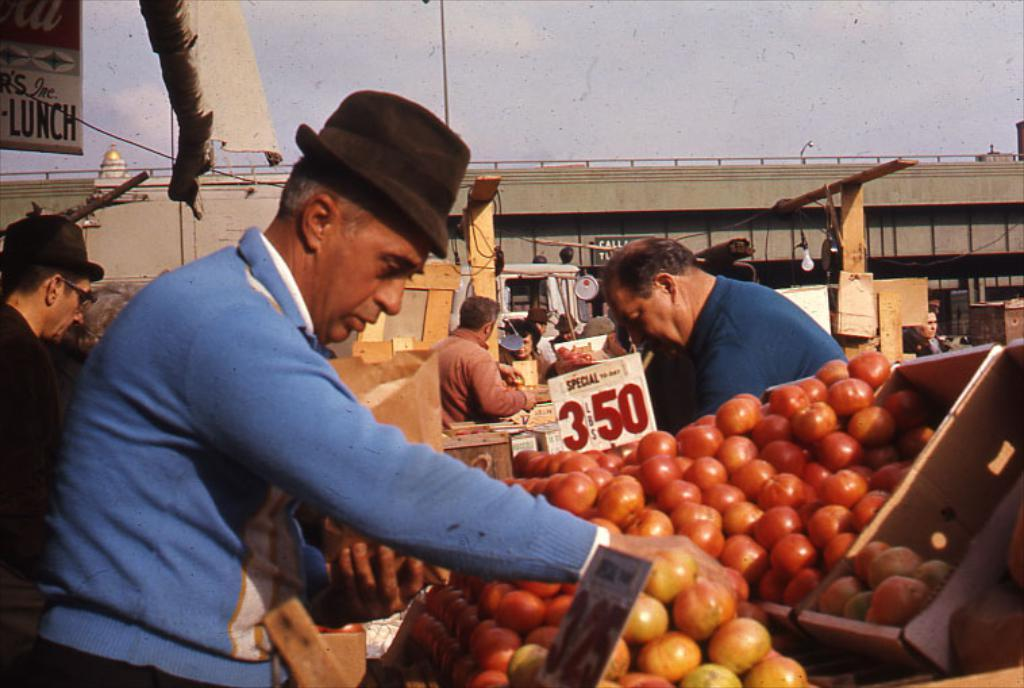How many people are in the image? The number of people in the image cannot be determined from the provided facts. What type of fruits are in the image? The type of fruits in the image cannot be determined from the provided facts. What is located in the middle of the image? There is a bridge in the middle of the image. What is visible at the top of the image? The sky is visible at the top of the image. What type of weather can be seen in the image? The provided facts do not mention any weather conditions, so it cannot be determined from the image. What attraction is present in the image? The provided facts do not mention any specific attractions, so it cannot be determined from the image. 